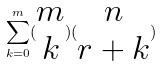Convert formula to latex. <formula><loc_0><loc_0><loc_500><loc_500>\sum _ { k = 0 } ^ { m } ( \begin{matrix} m \\ k \end{matrix} ) ( \begin{matrix} n \\ r + k \end{matrix} )</formula> 